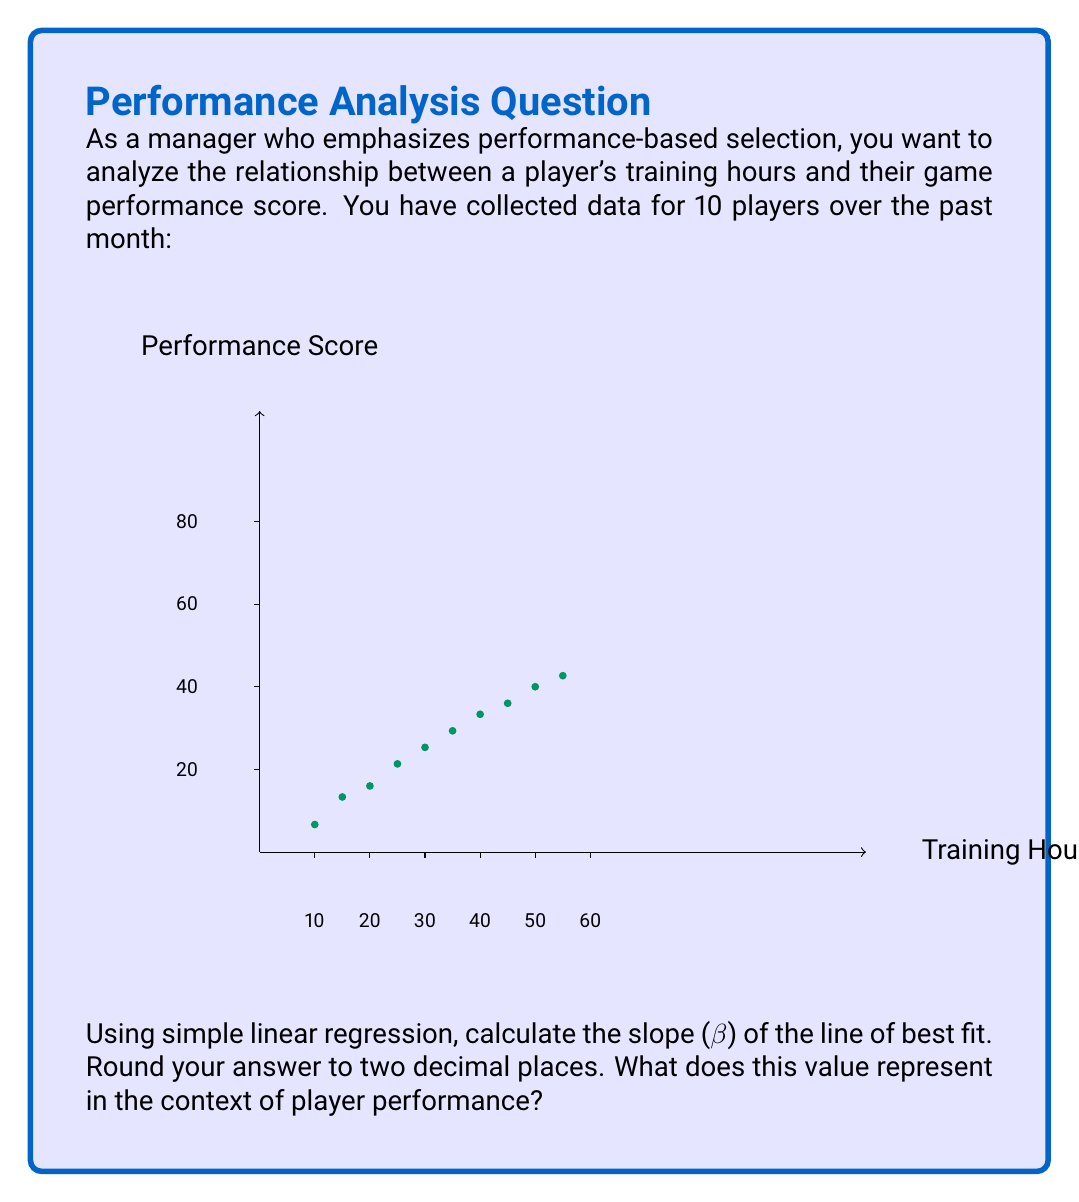Provide a solution to this math problem. To calculate the slope (β) of the line of best fit using simple linear regression, we'll use the formula:

$$ \beta = \frac{n\sum xy - \sum x \sum y}{n\sum x^2 - (\sum x)^2} $$

Where:
n = number of data points
x = training hours
y = performance score

Step 1: Calculate the necessary sums:
$\sum x = 325$
$\sum y = 798$
$\sum xy = 27,455$
$\sum x^2 = 13,625$
$n = 10$

Step 2: Plug these values into the formula:

$$ \beta = \frac{10(27,455) - (325)(798)}{10(13,625) - (325)^2} $$

Step 3: Solve the equation:

$$ \beta = \frac{274,550 - 259,350}{136,250 - 105,625} $$
$$ \beta = \frac{15,200}{30,625} $$
$$ \beta \approx 0.4963 $$

Step 4: Round to two decimal places:
$\beta = 0.50$

In the context of player performance, this slope represents the increase in performance score for each additional hour of training. Specifically, for every additional hour of training, a player's performance score is expected to increase by 0.50 points on average.
Answer: $\beta = 0.50$ (representing a 0.50 point increase in performance score per additional training hour) 